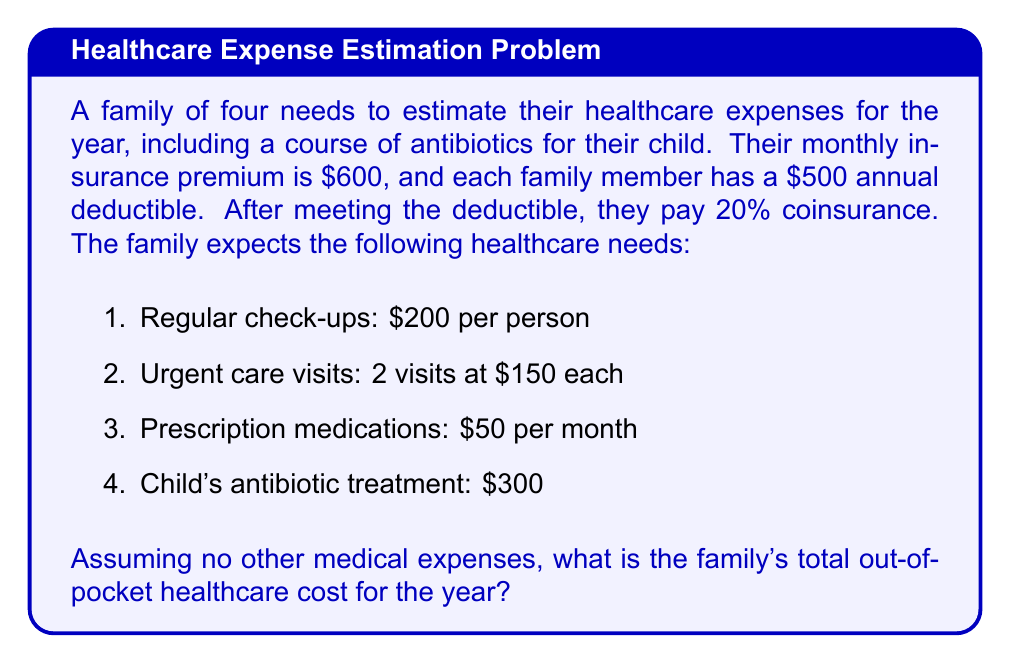Provide a solution to this math problem. Let's break this down step-by-step:

1. Calculate annual insurance premiums:
   $600 \times 12 = $7,200

2. Calculate total deductibles:
   $500 \times 4 = $2,000

3. Calculate expenses before meeting deductibles:
   a. Check-ups: $200 \times 4 = $800
   b. Urgent care: $150 \times 2 = $300
   c. Medications: $50 \times 12 = $600
   d. Antibiotics: $300

   Total: $800 + $300 + $600 + $300 = $2,000

4. Since the expenses exactly meet the deductibles, there's no coinsurance to pay.

5. Calculate total out-of-pocket costs:
   Annual premiums + Deductibles = $7,200 + $2,000 = $9,200

Therefore, the family's total out-of-pocket healthcare cost for the year is $9,200.
Answer: $9,200 